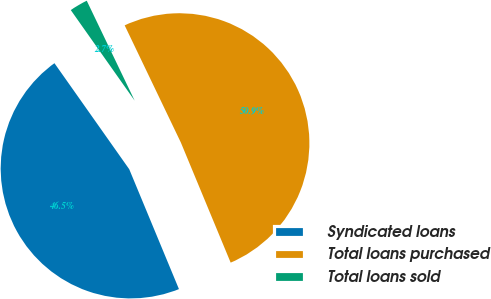<chart> <loc_0><loc_0><loc_500><loc_500><pie_chart><fcel>Syndicated loans<fcel>Total loans purchased<fcel>Total loans sold<nl><fcel>46.48%<fcel>50.86%<fcel>2.66%<nl></chart> 